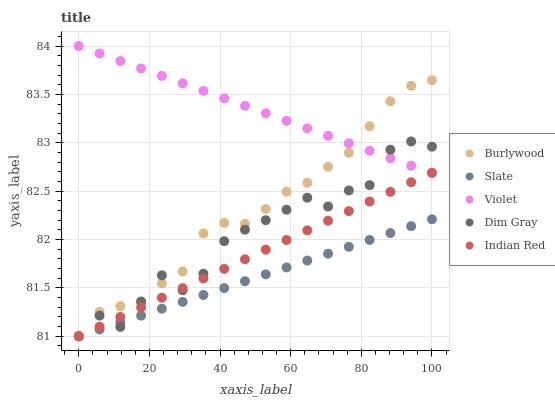Does Slate have the minimum area under the curve?
Answer yes or no. Yes. Does Violet have the maximum area under the curve?
Answer yes or no. Yes. Does Dim Gray have the minimum area under the curve?
Answer yes or no. No. Does Dim Gray have the maximum area under the curve?
Answer yes or no. No. Is Slate the smoothest?
Answer yes or no. Yes. Is Dim Gray the roughest?
Answer yes or no. Yes. Is Dim Gray the smoothest?
Answer yes or no. No. Is Slate the roughest?
Answer yes or no. No. Does Burlywood have the lowest value?
Answer yes or no. Yes. Does Violet have the lowest value?
Answer yes or no. No. Does Violet have the highest value?
Answer yes or no. Yes. Does Dim Gray have the highest value?
Answer yes or no. No. Is Slate less than Violet?
Answer yes or no. Yes. Is Violet greater than Slate?
Answer yes or no. Yes. Does Violet intersect Dim Gray?
Answer yes or no. Yes. Is Violet less than Dim Gray?
Answer yes or no. No. Is Violet greater than Dim Gray?
Answer yes or no. No. Does Slate intersect Violet?
Answer yes or no. No. 